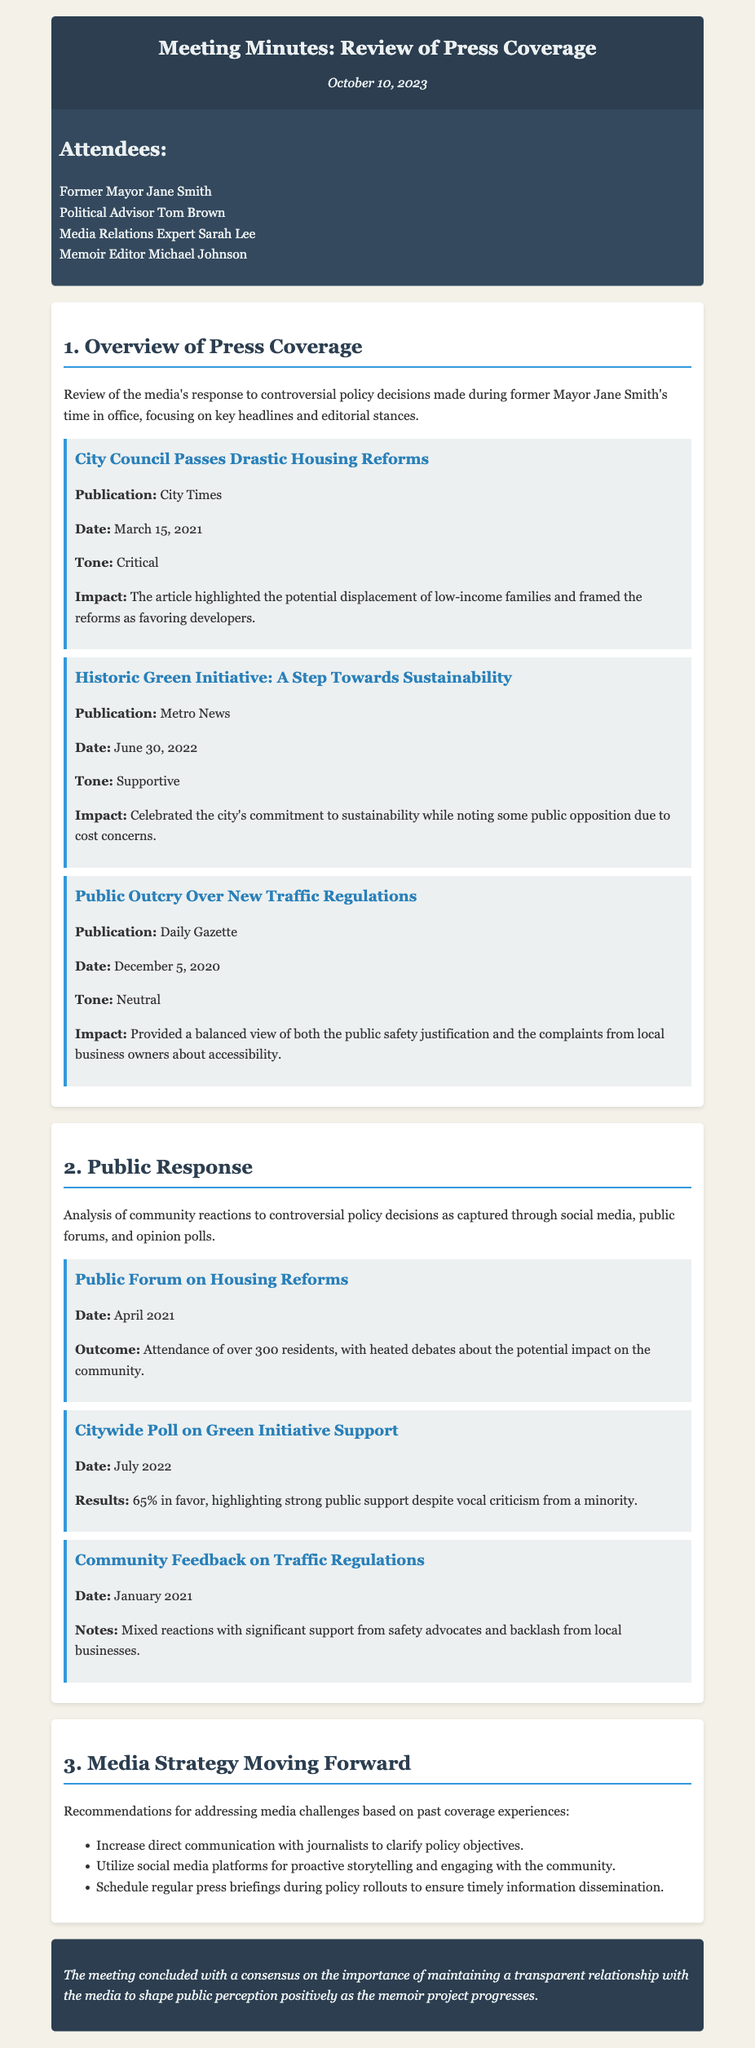What is the date of the meeting? The date of the meeting is stated at the top of the document in the header section.
Answer: October 10, 2023 Who attended the meeting as a media relations expert? The attendees section lists the individuals present during the meeting.
Answer: Sarah Lee What was the tone of the article titled "City Council Passes Drastic Housing Reforms"? The tone is mentioned in the overview of press coverage section for the highlighted article.
Answer: Critical How many residents attended the public forum on housing reforms? The outcome of the public forum is detailed in the public response section.
Answer: Over 300 What was the support percentage in the citywide poll on the Green Initiative? The results of the poll are provided in the analysis section of public response.
Answer: 65% What is one recommendation for media strategy moving forward? The recommendations are listed in the media strategy section of the document.
Answer: Increase direct communication with journalists What was the impact of the "Historic Green Initiative" article? The impact is noted in the overview of press coverage for the respective article.
Answer: Celebrated the city's commitment to sustainability Which publication wrote about the "Public Outcry Over New Traffic Regulations"? The publications are specified for each example in the overview of press coverage.
Answer: Daily Gazette 